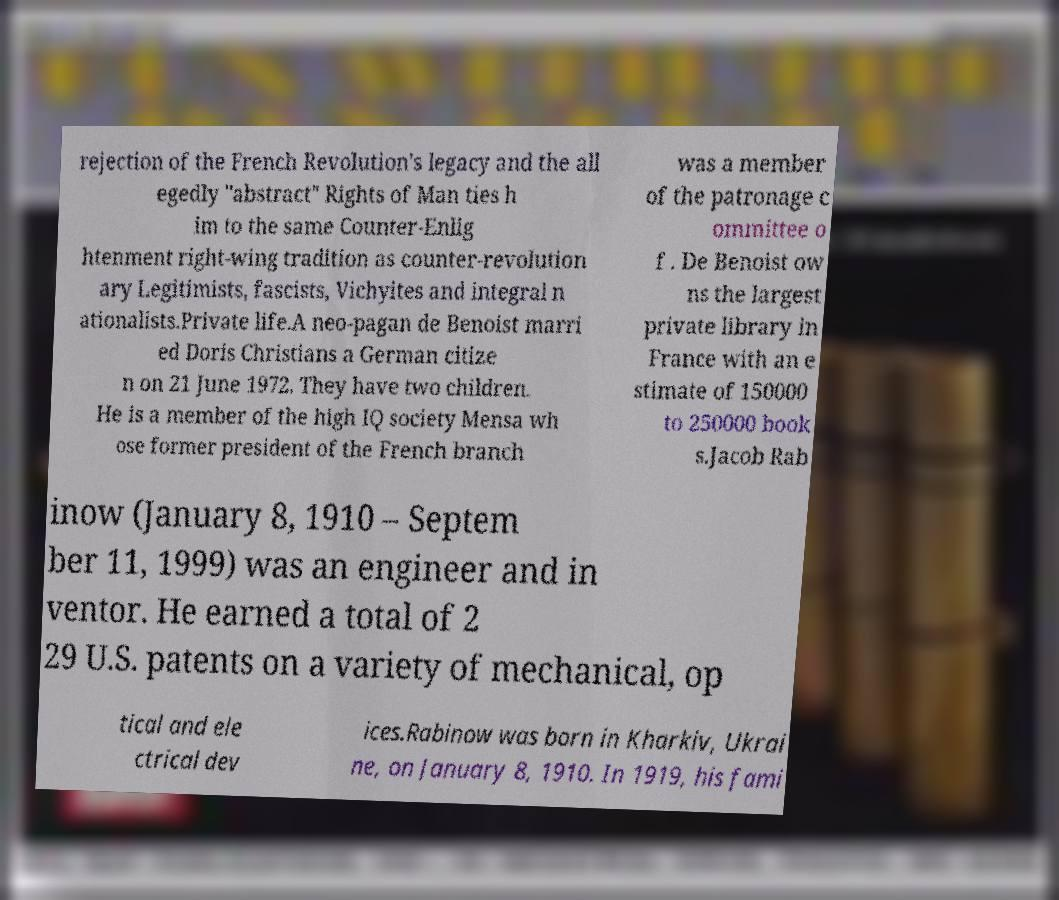Please read and relay the text visible in this image. What does it say? rejection of the French Revolution's legacy and the all egedly "abstract" Rights of Man ties h im to the same Counter-Enlig htenment right-wing tradition as counter-revolution ary Legitimists, fascists, Vichyites and integral n ationalists.Private life.A neo-pagan de Benoist marri ed Doris Christians a German citize n on 21 June 1972. They have two children. He is a member of the high IQ society Mensa wh ose former president of the French branch was a member of the patronage c ommittee o f . De Benoist ow ns the largest private library in France with an e stimate of 150000 to 250000 book s.Jacob Rab inow (January 8, 1910 – Septem ber 11, 1999) was an engineer and in ventor. He earned a total of 2 29 U.S. patents on a variety of mechanical, op tical and ele ctrical dev ices.Rabinow was born in Kharkiv, Ukrai ne, on January 8, 1910. In 1919, his fami 